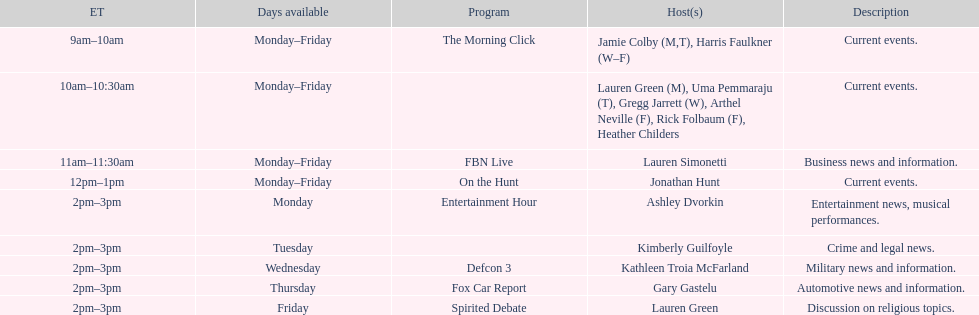On how many days of the week is fbn live aired? 5. Could you parse the entire table as a dict? {'header': ['ET', 'Days available', 'Program', 'Host(s)', 'Description'], 'rows': [['9am–10am', 'Monday–Friday', 'The Morning Click', 'Jamie Colby (M,T), Harris Faulkner (W–F)', 'Current events.'], ['10am–10:30am', 'Monday–Friday', '', 'Lauren Green (M), Uma Pemmaraju (T), Gregg Jarrett (W), Arthel Neville (F), Rick Folbaum (F), Heather Childers', 'Current events.'], ['11am–11:30am', 'Monday–Friday', 'FBN Live', 'Lauren Simonetti', 'Business news and information.'], ['12pm–1pm', 'Monday–Friday', 'On the Hunt', 'Jonathan Hunt', 'Current events.'], ['2pm–3pm', 'Monday', 'Entertainment Hour', 'Ashley Dvorkin', 'Entertainment news, musical performances.'], ['2pm–3pm', 'Tuesday', '', 'Kimberly Guilfoyle', 'Crime and legal news.'], ['2pm–3pm', 'Wednesday', 'Defcon 3', 'Kathleen Troia McFarland', 'Military news and information.'], ['2pm–3pm', 'Thursday', 'Fox Car Report', 'Gary Gastelu', 'Automotive news and information.'], ['2pm–3pm', 'Friday', 'Spirited Debate', 'Lauren Green', 'Discussion on religious topics.']]} 